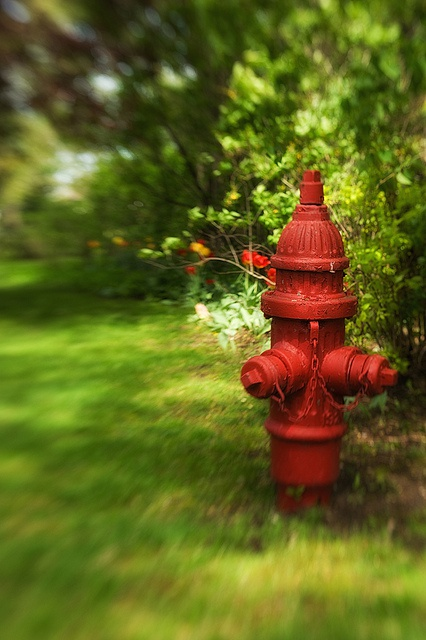Describe the objects in this image and their specific colors. I can see a fire hydrant in black, maroon, brown, and red tones in this image. 